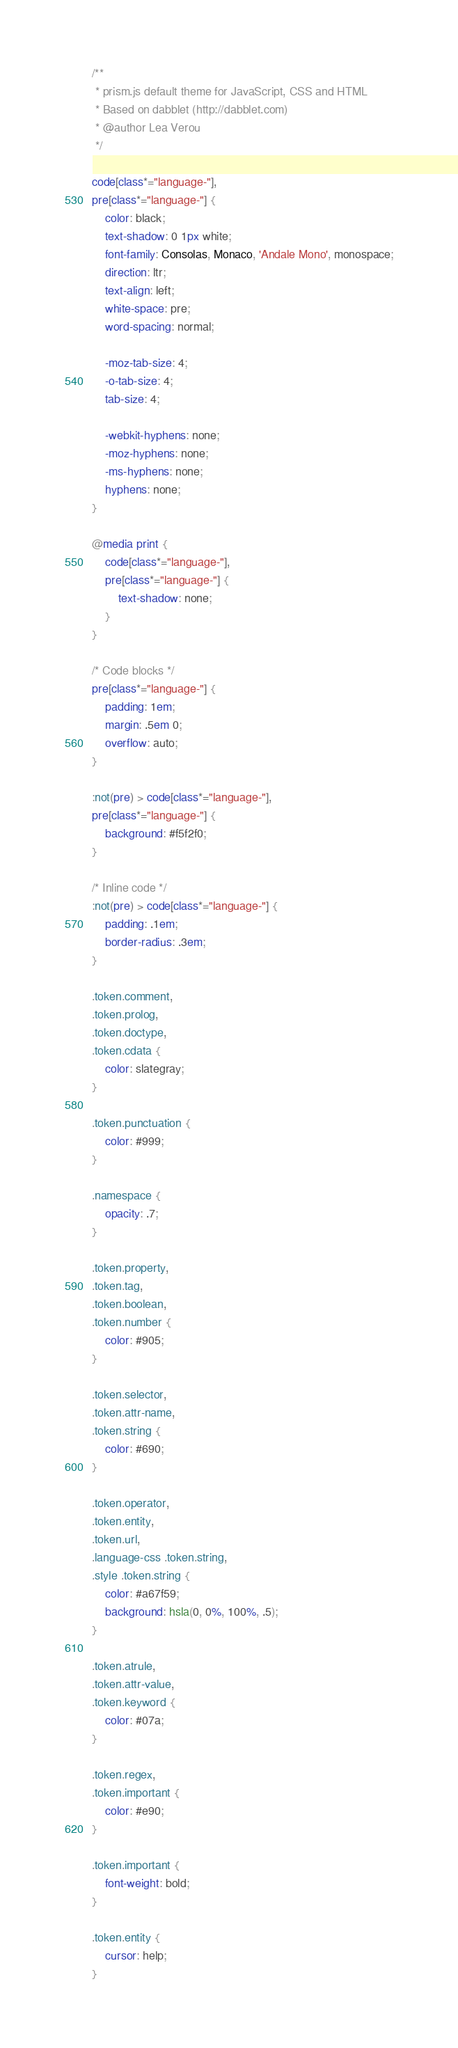<code> <loc_0><loc_0><loc_500><loc_500><_CSS_>/**
 * prism.js default theme for JavaScript, CSS and HTML
 * Based on dabblet (http://dabblet.com)
 * @author Lea Verou
 */

code[class*="language-"],
pre[class*="language-"] {
    color: black;
    text-shadow: 0 1px white;
    font-family: Consolas, Monaco, 'Andale Mono', monospace;
    direction: ltr;
    text-align: left;
    white-space: pre;
    word-spacing: normal;

    -moz-tab-size: 4;
    -o-tab-size: 4;
    tab-size: 4;

    -webkit-hyphens: none;
    -moz-hyphens: none;
    -ms-hyphens: none;
    hyphens: none;
}

@media print {
    code[class*="language-"],
    pre[class*="language-"] {
        text-shadow: none;
    }
}

/* Code blocks */
pre[class*="language-"] {
    padding: 1em;
    margin: .5em 0;
    overflow: auto;
}

:not(pre) > code[class*="language-"],
pre[class*="language-"] {
    background: #f5f2f0;
}

/* Inline code */
:not(pre) > code[class*="language-"] {
    padding: .1em;
    border-radius: .3em;
}

.token.comment,
.token.prolog,
.token.doctype,
.token.cdata {
    color: slategray;
}

.token.punctuation {
    color: #999;
}

.namespace {
    opacity: .7;
}

.token.property,
.token.tag,
.token.boolean,
.token.number {
    color: #905;
}

.token.selector,
.token.attr-name,
.token.string {
    color: #690;
}

.token.operator,
.token.entity,
.token.url,
.language-css .token.string,
.style .token.string {
    color: #a67f59;
    background: hsla(0, 0%, 100%, .5);
}

.token.atrule,
.token.attr-value,
.token.keyword {
    color: #07a;
}

.token.regex,
.token.important {
    color: #e90;
}

.token.important {
    font-weight: bold;
}

.token.entity {
    cursor: help;
}
</code> 